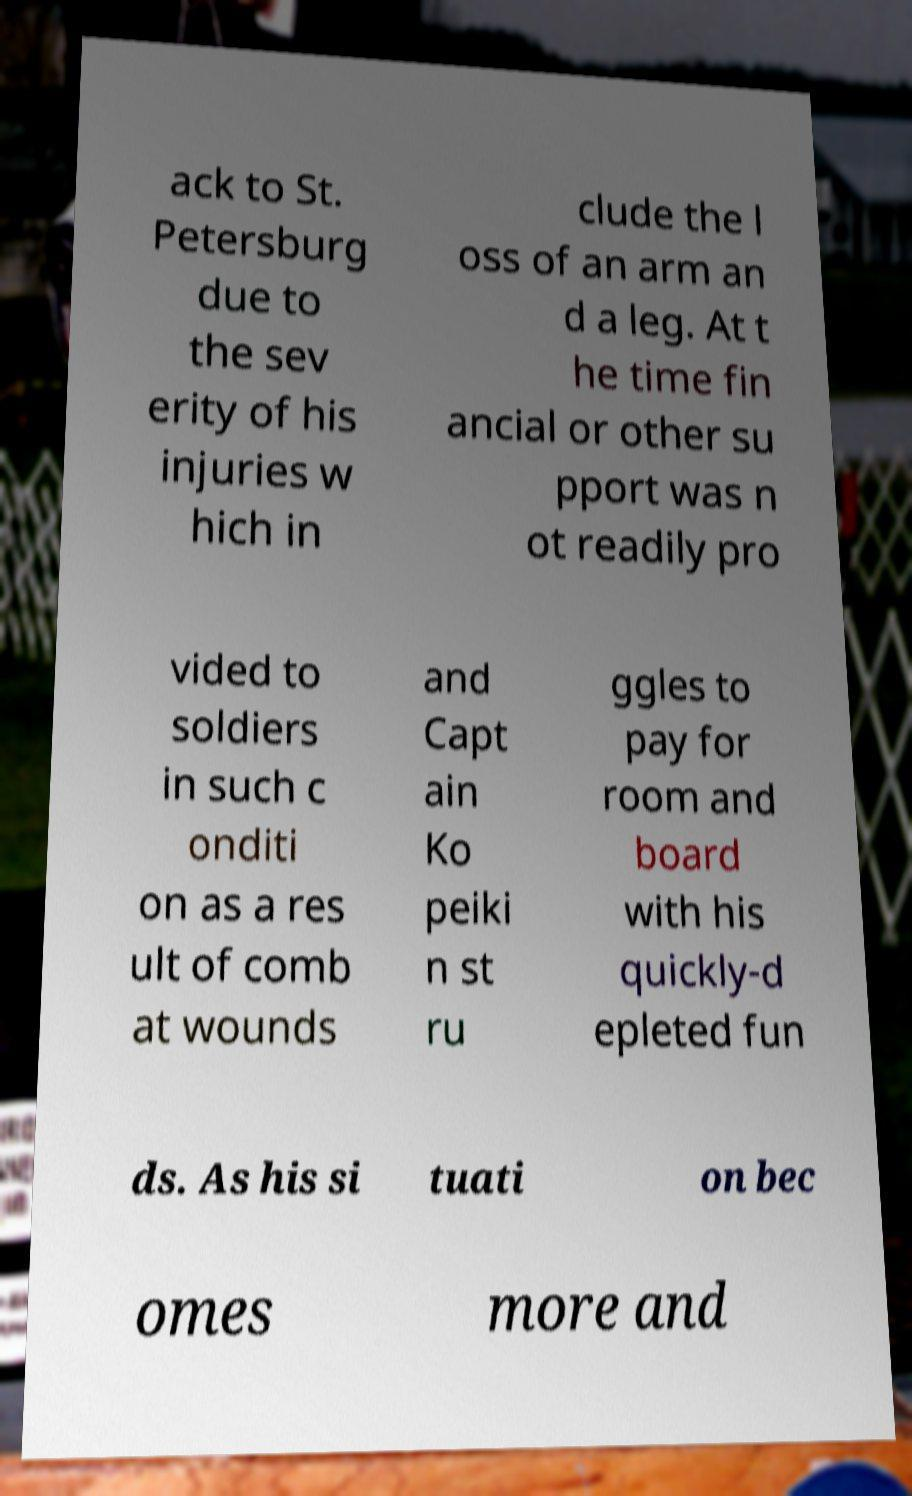There's text embedded in this image that I need extracted. Can you transcribe it verbatim? ack to St. Petersburg due to the sev erity of his injuries w hich in clude the l oss of an arm an d a leg. At t he time fin ancial or other su pport was n ot readily pro vided to soldiers in such c onditi on as a res ult of comb at wounds and Capt ain Ko peiki n st ru ggles to pay for room and board with his quickly-d epleted fun ds. As his si tuati on bec omes more and 